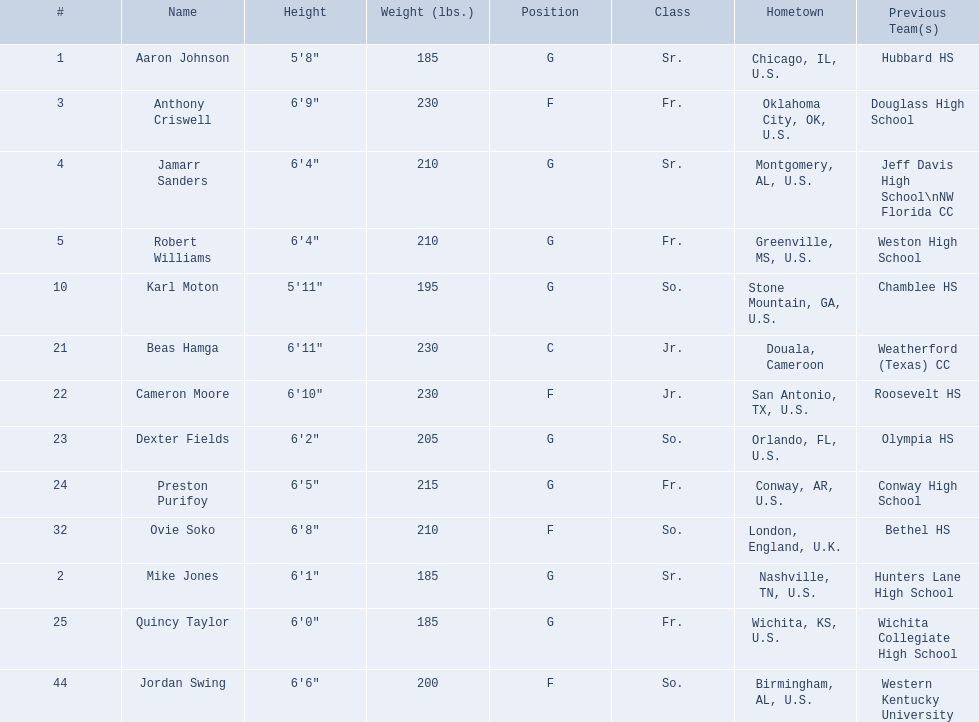Who are all the members? Aaron Johnson, Anthony Criswell, Jamarr Sanders, Robert Williams, Karl Moton, Beas Hamga, Cameron Moore, Dexter Fields, Preston Purifoy, Ovie Soko, Mike Jones, Quincy Taylor, Jordan Swing. Of these, which are not soko? Aaron Johnson, Anthony Criswell, Jamarr Sanders, Robert Williams, Karl Moton, Beas Hamga, Cameron Moore, Dexter Fields, Preston Purifoy, Mike Jones, Quincy Taylor, Jordan Swing. Where do these members come from? Sr., Fr., Sr., Fr., So., Jr., Jr., So., Fr., Sr., Fr., So. Of these origins, which are not in the u.s.? Jr. Which member is from this origin? Beas Hamga. 